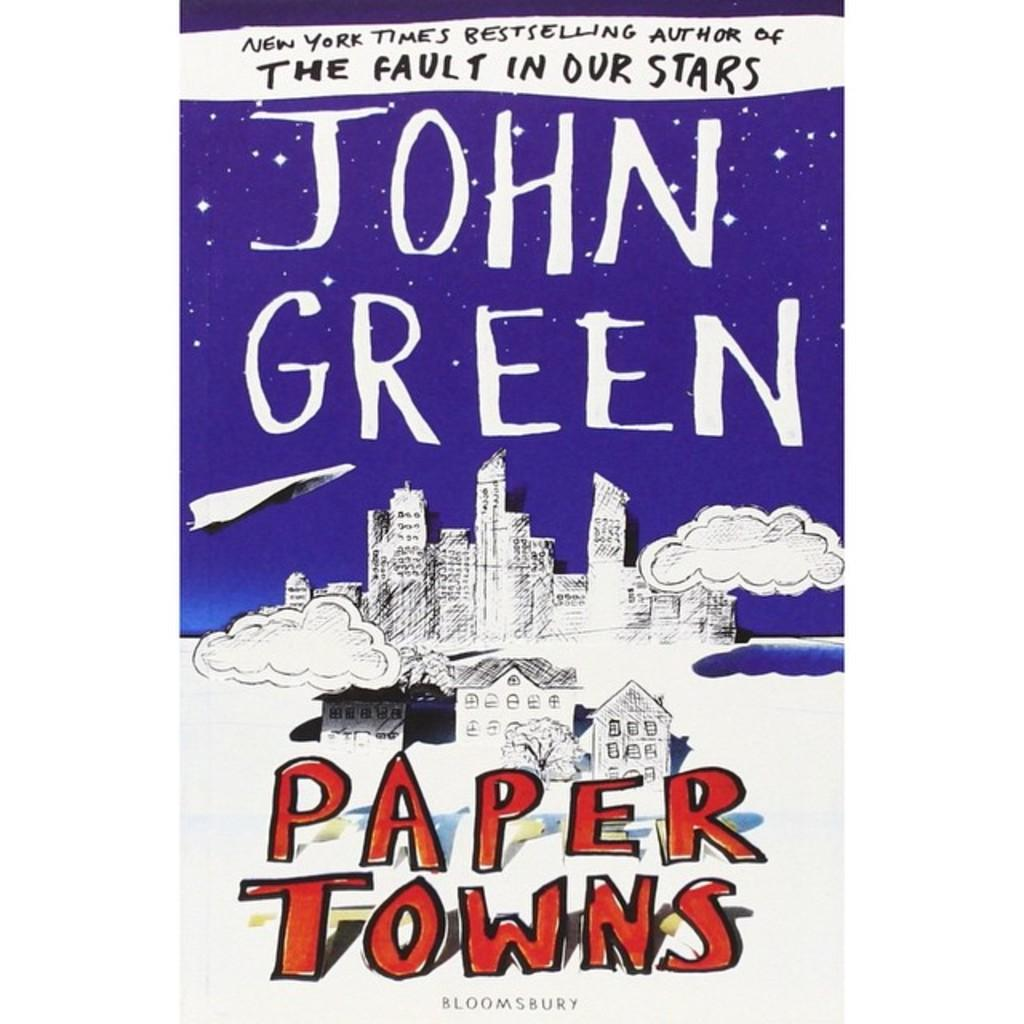Provide a one-sentence caption for the provided image. The blue and white cover of the book "Paper Towns" by John Green. 